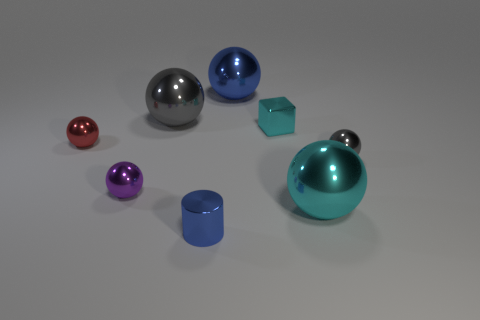Is the gray thing that is in front of the small red object made of the same material as the gray sphere that is left of the big blue shiny ball?
Provide a short and direct response. Yes. There is a cyan thing in front of the gray metal thing on the right side of the ball that is in front of the purple shiny object; what is its size?
Keep it short and to the point. Large. There is a cyan ball that is the same size as the blue metal sphere; what material is it?
Give a very brief answer. Metal. Are there any purple balls of the same size as the cyan metal block?
Offer a terse response. Yes. Does the large cyan shiny object have the same shape as the tiny gray thing?
Offer a very short reply. Yes. Is there a small red ball in front of the gray metallic thing behind the red ball that is in front of the tiny shiny block?
Your response must be concise. Yes. There is a gray ball to the right of the blue cylinder; does it have the same size as the gray metallic ball that is behind the red metal object?
Provide a succinct answer. No. Is the number of red shiny balls right of the cyan metallic sphere the same as the number of large objects that are on the right side of the red ball?
Give a very brief answer. No. Is there any other thing that is the same material as the cylinder?
Your answer should be compact. Yes. Does the purple metal sphere have the same size as the cyan metallic thing in front of the red thing?
Offer a very short reply. No. 